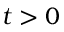<formula> <loc_0><loc_0><loc_500><loc_500>t > 0</formula> 